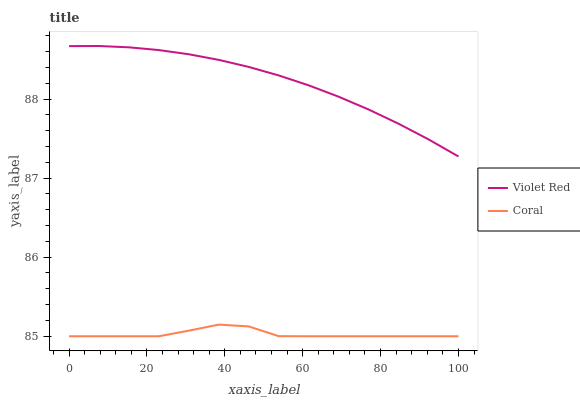Does Coral have the minimum area under the curve?
Answer yes or no. Yes. Does Violet Red have the maximum area under the curve?
Answer yes or no. Yes. Does Coral have the maximum area under the curve?
Answer yes or no. No. Is Violet Red the smoothest?
Answer yes or no. Yes. Is Coral the roughest?
Answer yes or no. Yes. Is Coral the smoothest?
Answer yes or no. No. Does Coral have the lowest value?
Answer yes or no. Yes. Does Violet Red have the highest value?
Answer yes or no. Yes. Does Coral have the highest value?
Answer yes or no. No. Is Coral less than Violet Red?
Answer yes or no. Yes. Is Violet Red greater than Coral?
Answer yes or no. Yes. Does Coral intersect Violet Red?
Answer yes or no. No. 